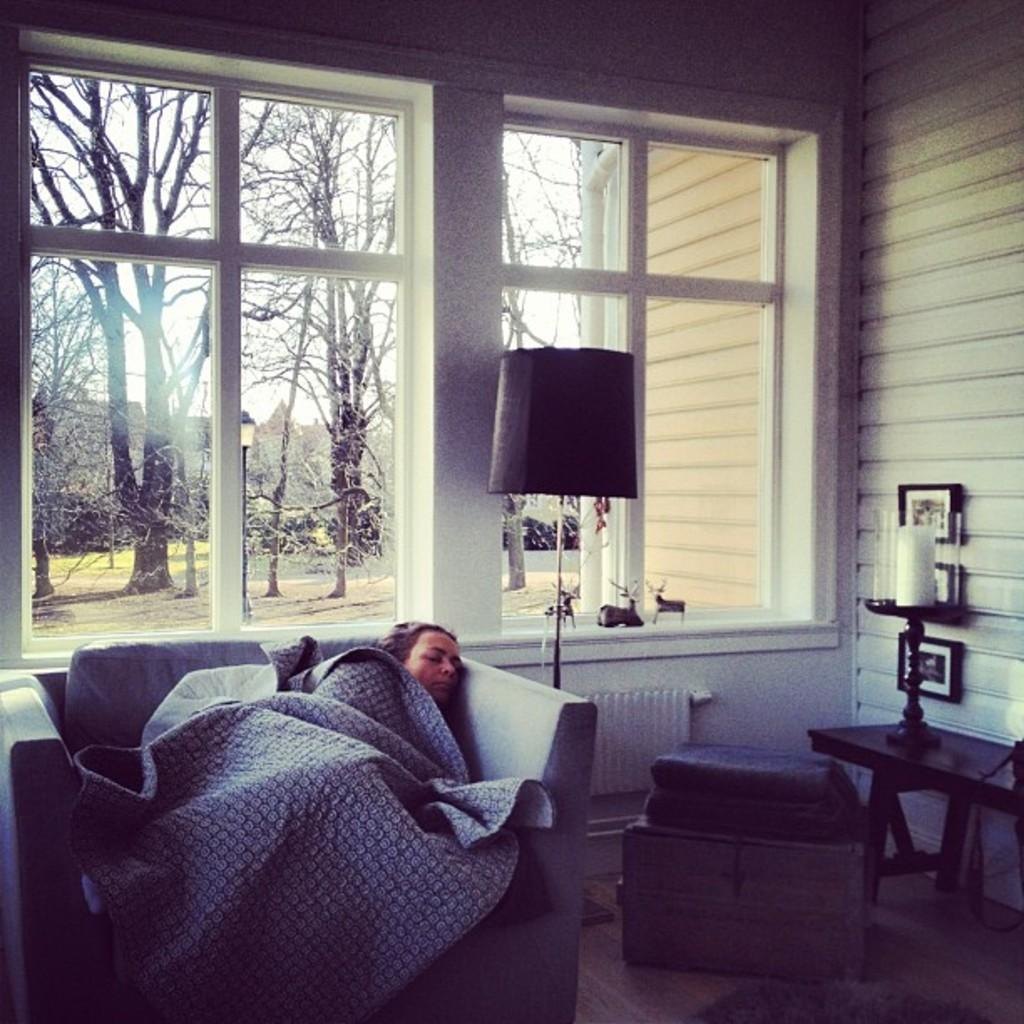What is the woman in the image doing? The woman is sleeping on a sofa. What can be seen in the room besides the woman? There is a lamp in the room. What is present on the windows in the room? There are window glasses in the room. What can be seen outside the window? Trees are visible outside the window. What is on the right side of the image? There is a wall on the right side of the image. What decision is the woman making while sleeping in the image? The woman is not making any decisions while sleeping in the image; she is simply sleeping. What type of board is present in the image? There is no board present in the image. 